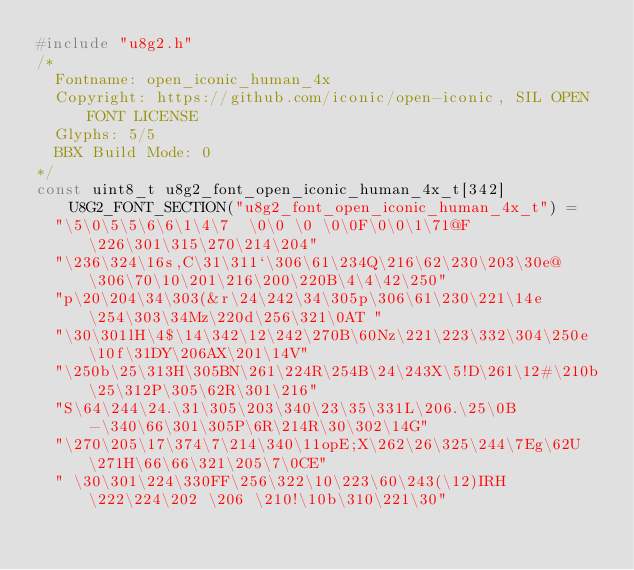<code> <loc_0><loc_0><loc_500><loc_500><_C_>#include "u8g2.h"
/*
  Fontname: open_iconic_human_4x
  Copyright: https://github.com/iconic/open-iconic, SIL OPEN FONT LICENSE
  Glyphs: 5/5
  BBX Build Mode: 0
*/
const uint8_t u8g2_font_open_iconic_human_4x_t[342] U8G2_FONT_SECTION("u8g2_font_open_iconic_human_4x_t") = 
  "\5\0\5\5\6\6\1\4\7  \0\0 \0 \0\0F\0\0\1\71@F \226\301\315\270\214\204"
  "\236\324\16s,C\31\311`\306\61\234Q\216\62\230\203\30e@\306\70\10\201\216\200\220B\4\4\42\250"
  "p\20\204\34\303(&r\24\242\34\305p\306\61\230\221\14e\254\303\34Mz\220d\256\321\0AT "
  "\30\301lH\4$\14\342\12\242\270B\60Nz\221\223\332\304\250e\10f\31DY\206AX\201\14V"
  "\250b\25\313H\305BN\261\224R\254B\24\243X\5!D\261\12#\210b\25\312P\305\62R\301\216"
  "S\64\244\24.\31\305\203\340\23\35\331L\206.\25\0B-\340\66\301\305P\6R\214R\30\302\14G"
  "\270\205\17\374\7\214\340\11opE;X\262\26\325\244\7Eg\62U\271H\66\66\321\205\7\0CE"
  " \30\301\224\330FF\256\322\10\223\60\243(\12)IRH\222\224\202 \206 \210!\10b\310\221\30"</code> 